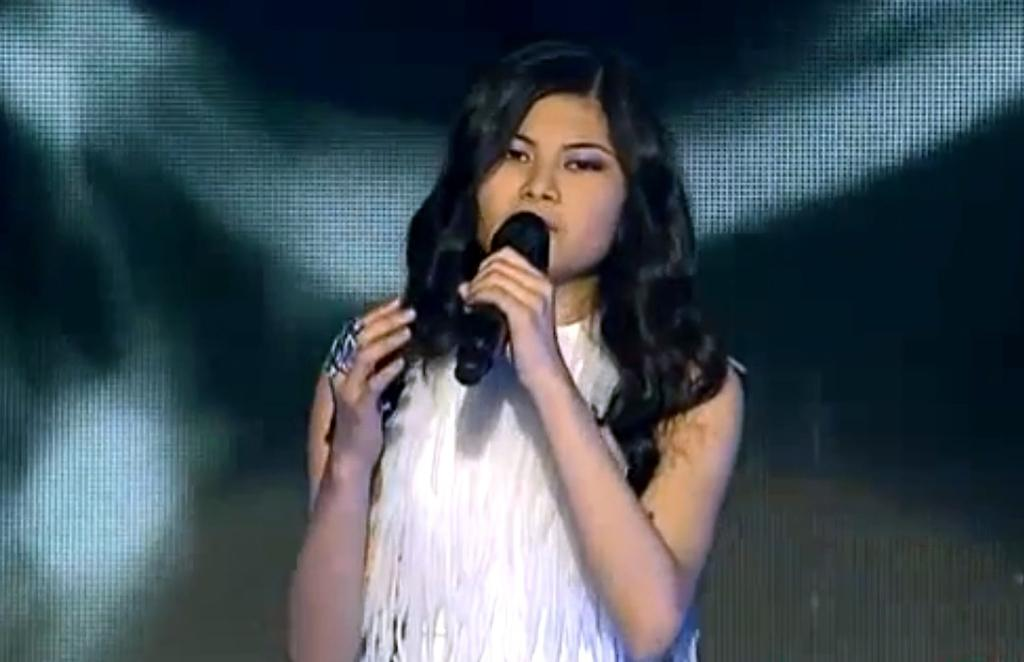Who is the main subject in the image? There is a lady in the image. What is the lady wearing? The lady is wearing a dress. What object is the lady holding in her hand? The lady is holding a microphone in her hand. What type of scarecrow can be seen in the image? There is no scarecrow present in the image; it features a lady holding a microphone. Can you tell me how many planets are visible in the image? There are no planets visible in the image, as it does not depict a space scene. 